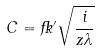Convert formula to latex. <formula><loc_0><loc_0><loc_500><loc_500>C = \Psi ^ { \prime } \sqrt { \frac { i } { z \lambda } }</formula> 